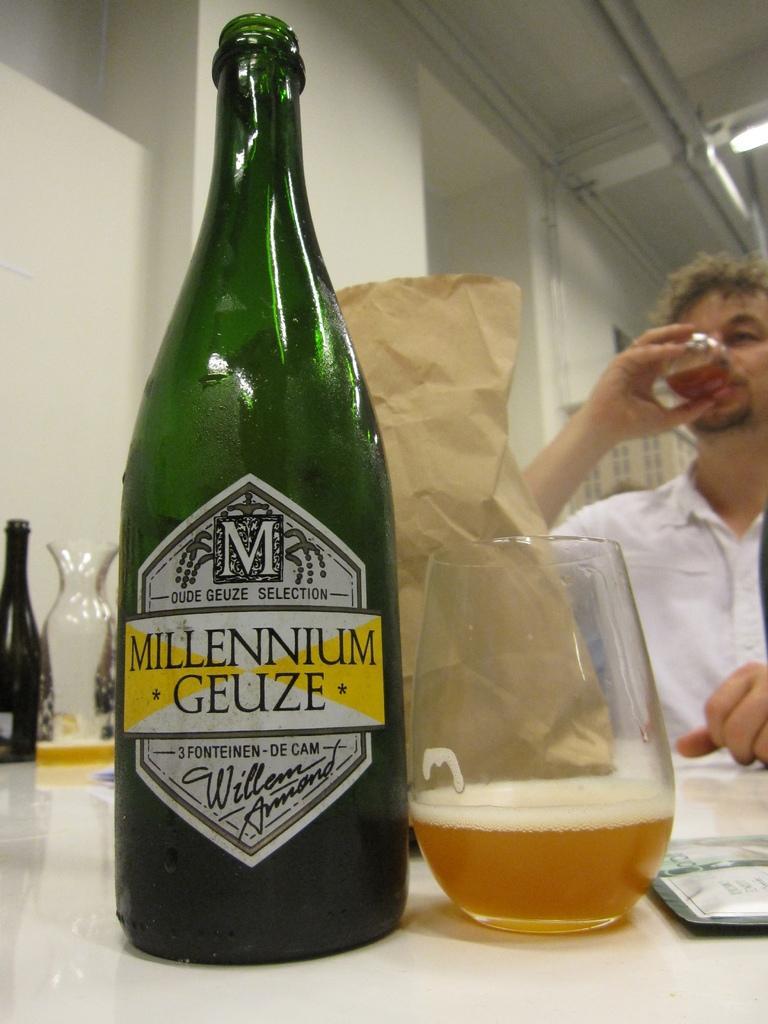Please provide a concise description of this image. In this image I can see a bottle and a glass. Here I can see a man is holding a glass and he is wearing white shirt. I can also see one more bottle over here. 